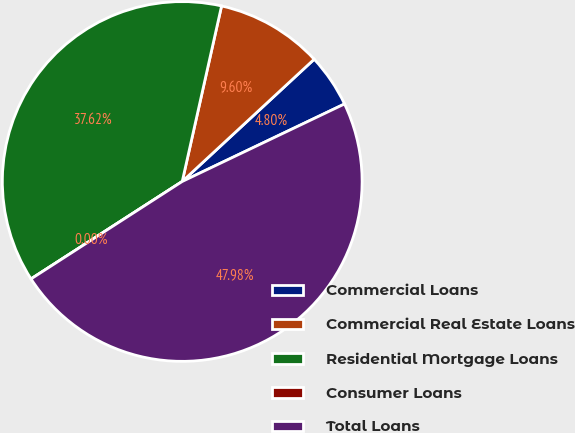Convert chart to OTSL. <chart><loc_0><loc_0><loc_500><loc_500><pie_chart><fcel>Commercial Loans<fcel>Commercial Real Estate Loans<fcel>Residential Mortgage Loans<fcel>Consumer Loans<fcel>Total Loans<nl><fcel>4.8%<fcel>9.6%<fcel>37.62%<fcel>0.0%<fcel>47.98%<nl></chart> 